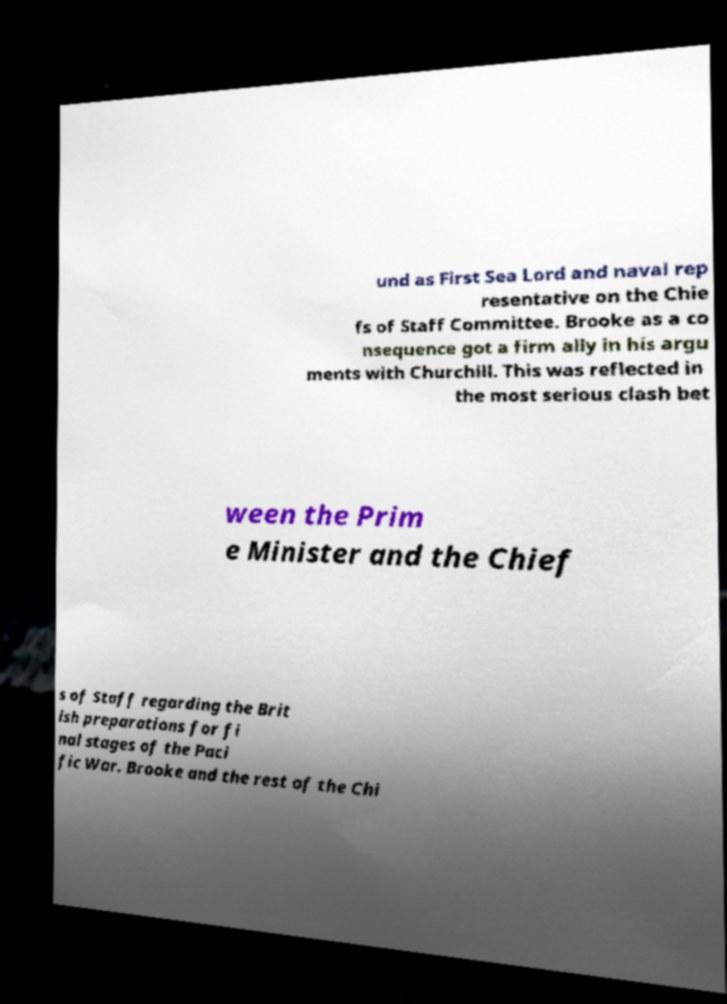Can you accurately transcribe the text from the provided image for me? und as First Sea Lord and naval rep resentative on the Chie fs of Staff Committee. Brooke as a co nsequence got a firm ally in his argu ments with Churchill. This was reflected in the most serious clash bet ween the Prim e Minister and the Chief s of Staff regarding the Brit ish preparations for fi nal stages of the Paci fic War. Brooke and the rest of the Chi 